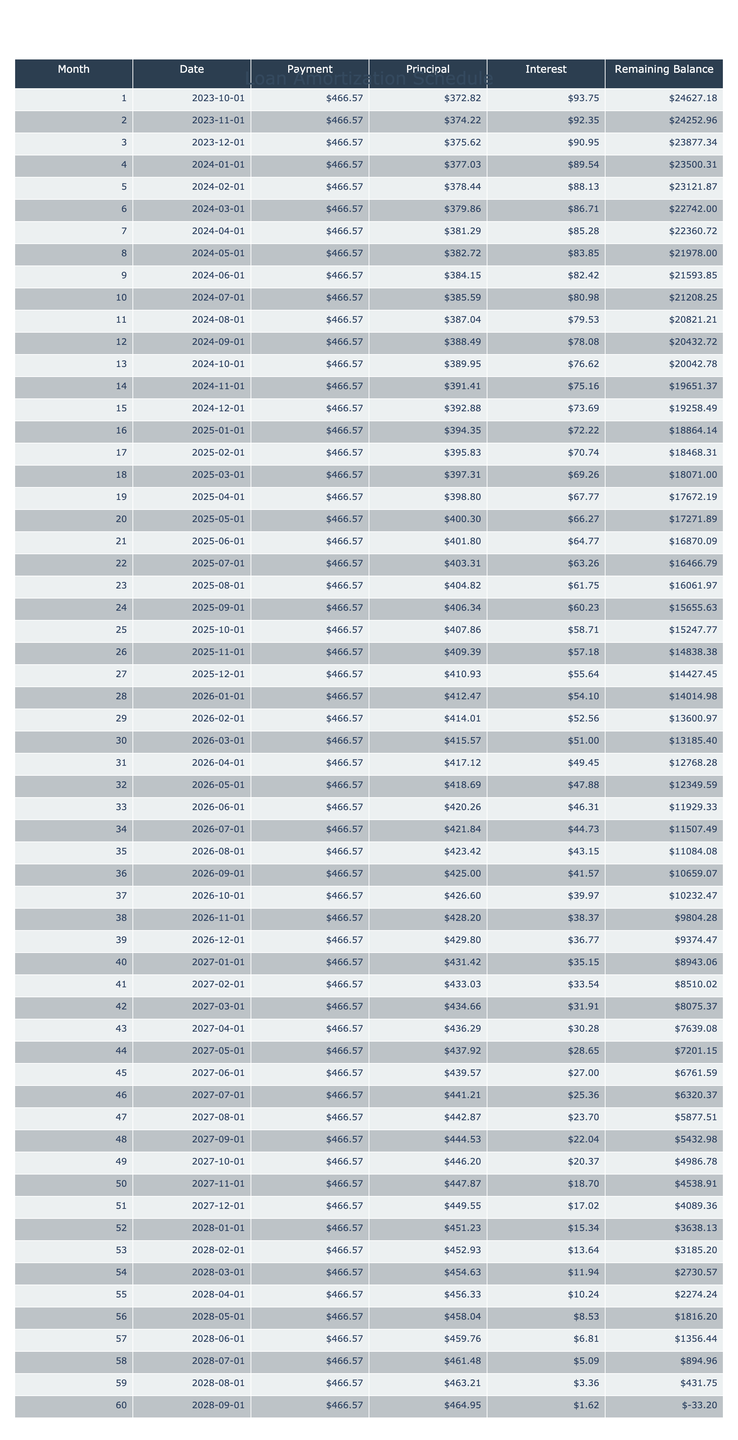What is the loan amount for the vehicle purchase? The loan amount is clearly stated in the table under the "Loan Amount" column, which shows $25,000.
Answer: $25,000 What is the total payment over the loan term? The total payment is shown in the "Total Payment" column of the table as $27,994.20.
Answer: $27,994.20 How much interest will be paid over the loan term? The total interest paid over the term is displayed in the "Total Interest" column, which is $2,994.20.
Answer: $2,994.20 Is the monthly payment greater than $450? The monthly payment listed is $466.57, which is indeed greater than $450.
Answer: Yes What is the remaining balance after the first payment? To find the remaining balance after the first payment, we look at the "Remaining Balance" after the first month. The remaining balance after the first payment is $24,533.43.
Answer: $24,533.43 What percentage of the monthly payment goes towards interest in the first month? In the first month, the interest payment is the same as the monthly payment of $466.57 minus the principal payment which can be calculated as $466.57 - ($25,000 * 0.00375) = $466.57 - $93.75 = $372.82 for principal, which means $93.75 of the payment is interest. The proportion of the interest payment to the total monthly payment is therefore ($93.75 / $466.57) * 100 = 20.06%.
Answer: 20.06% What will be the remaining balance after three payments? To find the remaining balance after three payments, we need to examine the "Remaining Balance" column for month three; this shows the amount left to be paid off after the third month which is $23,230.62.
Answer: $23,230.62 How much total will be paid in principal after the first year? The total principal paid in the first year (12 months) can be calculated by summing the principal payments from month 1 to month 12. Finding each month’s principal payment from the table, we sum these values which is $3,571.36 after 12 months.
Answer: $3,571.36 If the interest rate were 5% instead of 4.5%, would the monthly payment remain the same? The monthly payment will change if the interest rate is increased to 5% as it directly affects how much interest accumulates. Since the monthly payment is calculated based on the loan amount and interest, increasing the rate would produce a higher monthly payment.
Answer: No 